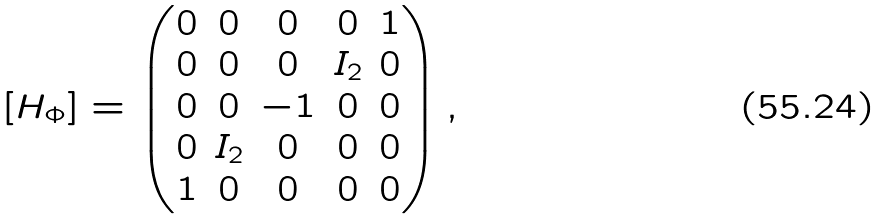<formula> <loc_0><loc_0><loc_500><loc_500>[ H _ { \Phi } ] = \begin{pmatrix} 0 & 0 & 0 & 0 & 1 \\ 0 & 0 & 0 & I _ { 2 } & 0 \\ 0 & 0 & - 1 & 0 & 0 \\ 0 & I _ { 2 } & 0 & 0 & 0 \\ 1 & 0 & 0 & 0 & 0 \end{pmatrix} ,</formula> 